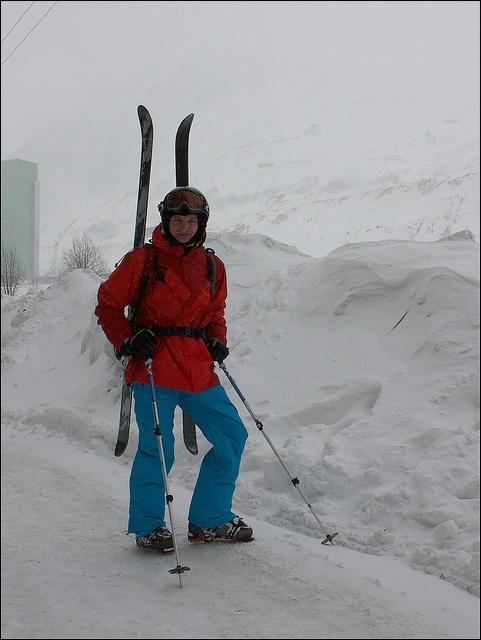How many people?
Give a very brief answer. 1. How many backpacks are in the picture?
Give a very brief answer. 1. 